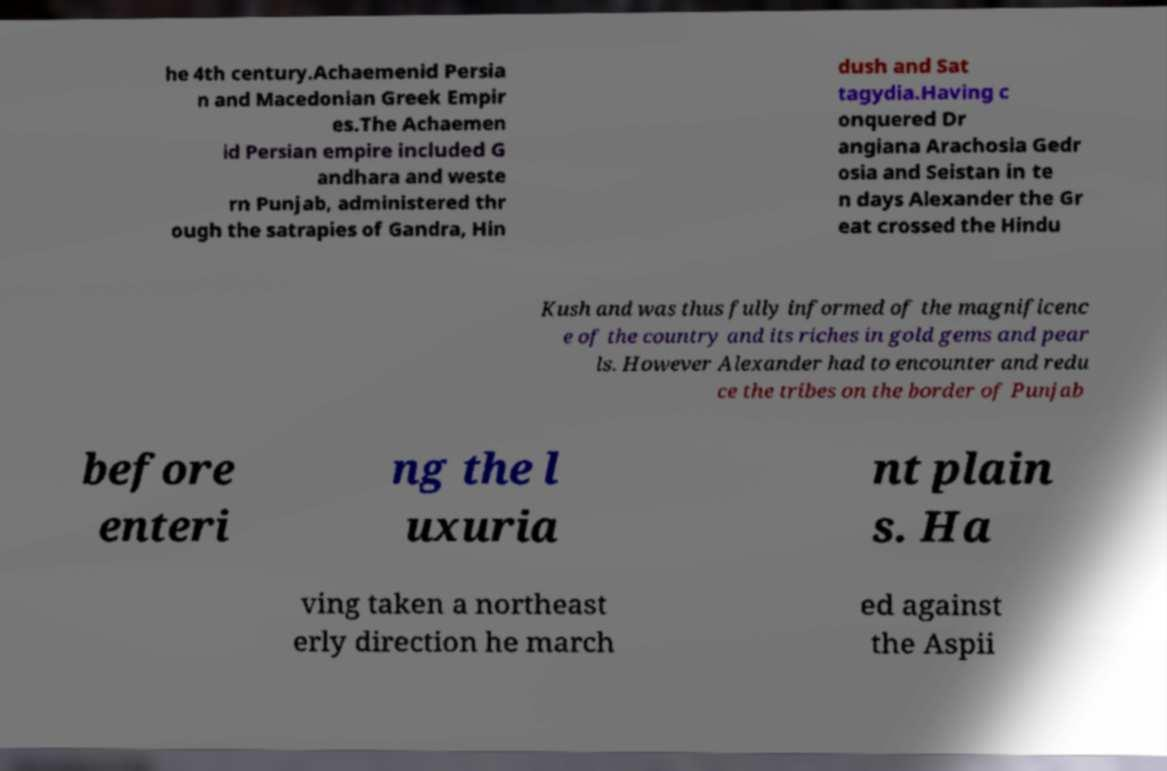What messages or text are displayed in this image? I need them in a readable, typed format. he 4th century.Achaemenid Persia n and Macedonian Greek Empir es.The Achaemen id Persian empire included G andhara and weste rn Punjab, administered thr ough the satrapies of Gandra, Hin dush and Sat tagydia.Having c onquered Dr angiana Arachosia Gedr osia and Seistan in te n days Alexander the Gr eat crossed the Hindu Kush and was thus fully informed of the magnificenc e of the country and its riches in gold gems and pear ls. However Alexander had to encounter and redu ce the tribes on the border of Punjab before enteri ng the l uxuria nt plain s. Ha ving taken a northeast erly direction he march ed against the Aspii 